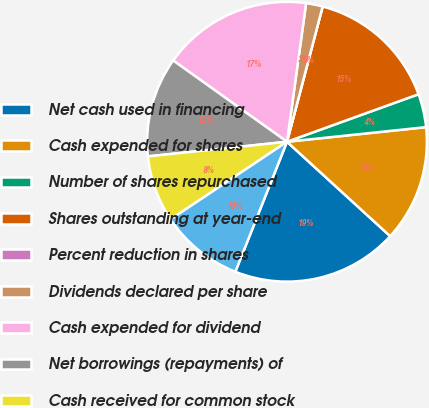Convert chart to OTSL. <chart><loc_0><loc_0><loc_500><loc_500><pie_chart><fcel>Net cash used in financing<fcel>Cash expended for shares<fcel>Number of shares repurchased<fcel>Shares outstanding at year-end<fcel>Percent reduction in shares<fcel>Dividends declared per share<fcel>Cash expended for dividend<fcel>Net borrowings (repayments) of<fcel>Cash received for common stock<fcel>Other financing activities<nl><fcel>19.23%<fcel>13.46%<fcel>3.85%<fcel>15.38%<fcel>0.0%<fcel>1.92%<fcel>17.31%<fcel>11.54%<fcel>7.69%<fcel>9.62%<nl></chart> 